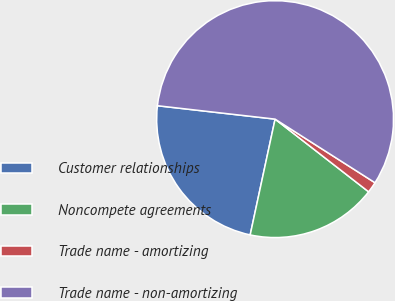Convert chart to OTSL. <chart><loc_0><loc_0><loc_500><loc_500><pie_chart><fcel>Customer relationships<fcel>Noncompete agreements<fcel>Trade name - amortizing<fcel>Trade name - non-amortizing<nl><fcel>23.43%<fcel>17.86%<fcel>1.49%<fcel>57.22%<nl></chart> 